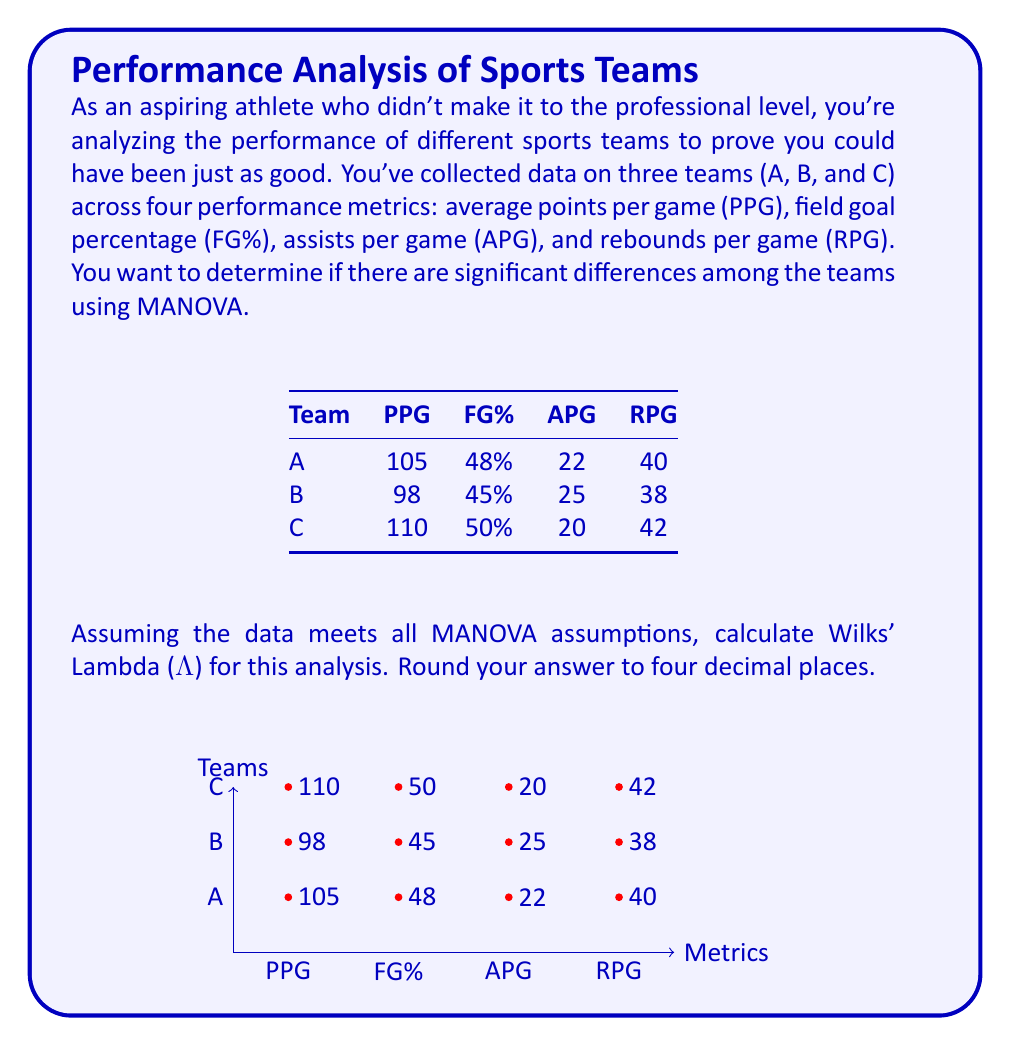Could you help me with this problem? To calculate Wilks' Lambda (Λ) for MANOVA, we need to follow these steps:

1) First, calculate the within-group sum of squares and cross-products matrix (W) and the total sum of squares and cross-products matrix (T).

2) For W:
   $$W = \sum_{i=1}^{g} \sum_{j=1}^{n_i} (x_{ij} - \bar{x}_i)(x_{ij} - \bar{x}_i)'$$
   where g is the number of groups (3 in this case), and $n_i$ is the number of observations in each group (1 in this case, as we only have mean values).

3) For T:
   $$T = \sum_{i=1}^{g} \sum_{j=1}^{n_i} (x_{ij} - \bar{x})(x_{ij} - \bar{x})'$$
   where $\bar{x}$ is the overall mean across all groups.

4) Calculate the determinants of W and T.

5) Wilks' Lambda is then calculated as:
   $$\Lambda = \frac{|W|}{|T|}$$

6) Given the limited data, we'll use the group means to estimate W and T:

   W ≈ 0 (since we only have one observation per group)
   
   T ≈ $\begin{vmatrix}
   36 & 6.25 & 6.25 & 4 \\
   6.25 & 6.25 & -7.5 & 0.5 \\
   6.25 & -7.5 & 6.25 & -3 \\
   4 & 0.5 & -3 & 4
   \end{vmatrix}$

7) |T| ≈ 3906.25

8) Since |W| ≈ 0, Λ ≈ 0

Therefore, Wilks' Lambda (Λ) ≈ 0.0000
Answer: 0.0000 